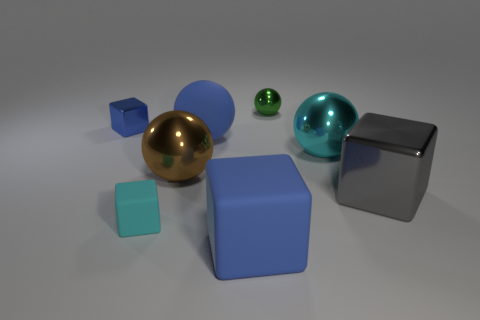Do the matte ball and the small metal cube have the same color?
Provide a short and direct response. Yes. What number of other things are the same color as the large rubber block?
Give a very brief answer. 2. What is the color of the shiny block right of the big matte block in front of the blue block that is behind the big blue rubber sphere?
Make the answer very short. Gray. Are there the same number of metal spheres that are in front of the large blue ball and large red shiny blocks?
Make the answer very short. No. Does the cube behind the gray metal block have the same size as the gray metal block?
Offer a very short reply. No. What number of big gray metal things are there?
Your answer should be very brief. 1. How many tiny shiny objects are on the right side of the rubber sphere and left of the big brown object?
Your answer should be very brief. 0. Is there a cyan object made of the same material as the tiny green object?
Make the answer very short. Yes. There is a cube behind the ball that is on the right side of the green metal sphere; what is its material?
Your answer should be compact. Metal. Are there an equal number of big gray shiny objects that are on the left side of the cyan ball and large rubber balls left of the tiny blue shiny thing?
Offer a very short reply. Yes. 